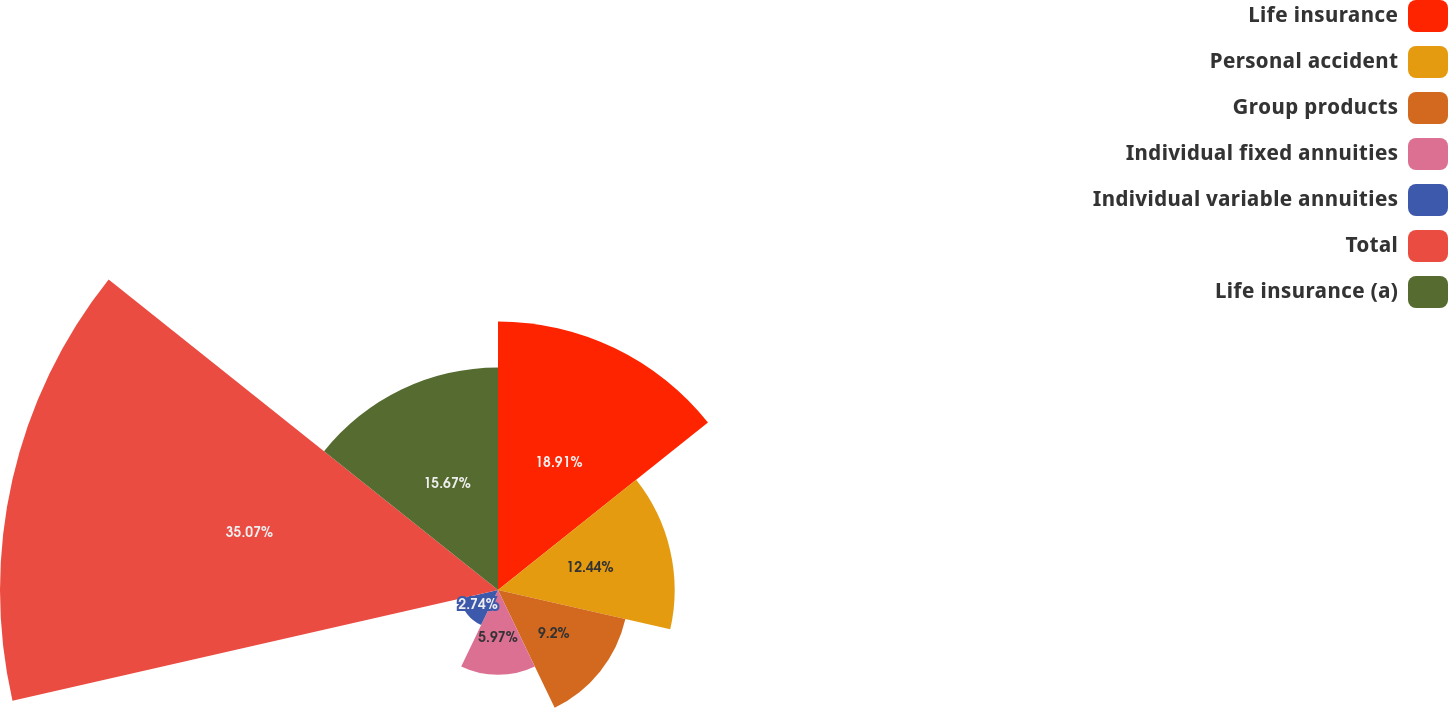Convert chart. <chart><loc_0><loc_0><loc_500><loc_500><pie_chart><fcel>Life insurance<fcel>Personal accident<fcel>Group products<fcel>Individual fixed annuities<fcel>Individual variable annuities<fcel>Total<fcel>Life insurance (a)<nl><fcel>18.91%<fcel>12.44%<fcel>9.2%<fcel>5.97%<fcel>2.74%<fcel>35.07%<fcel>15.67%<nl></chart> 